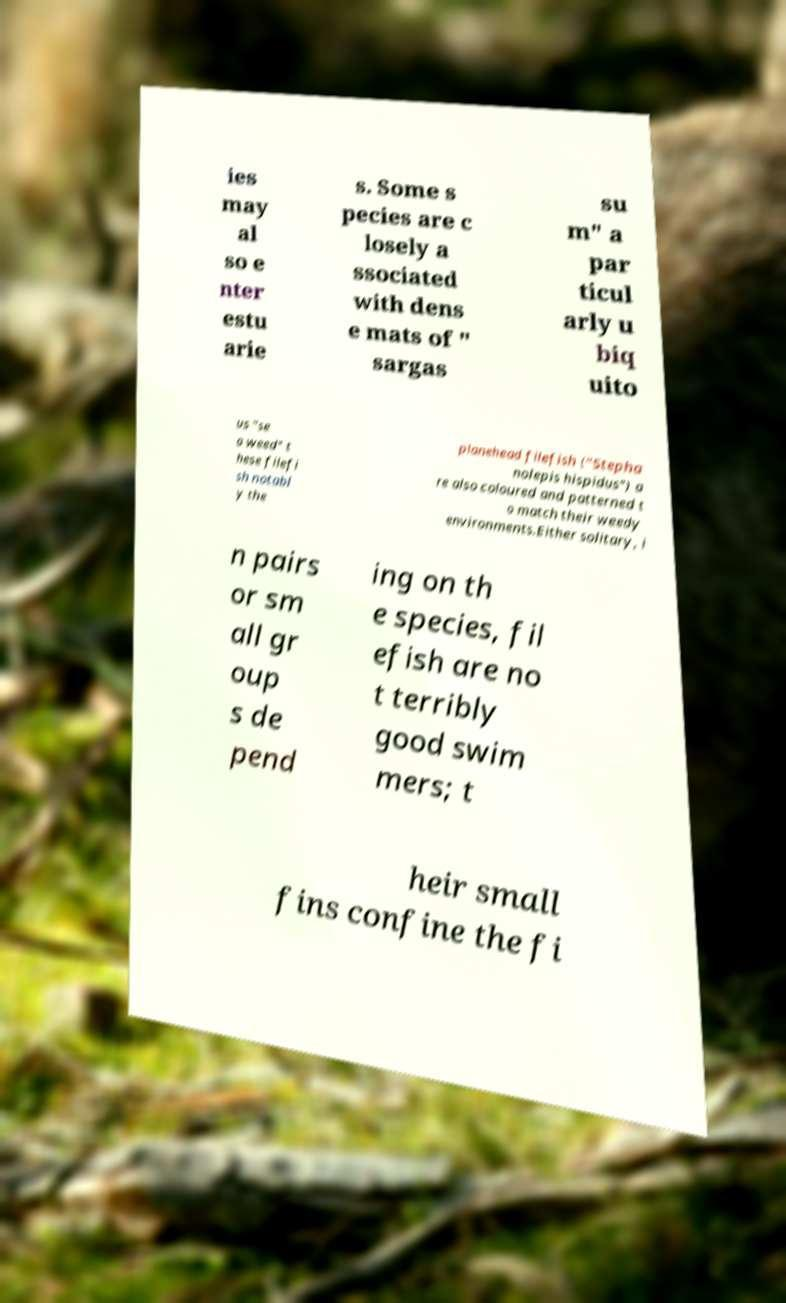Please read and relay the text visible in this image. What does it say? ies may al so e nter estu arie s. Some s pecies are c losely a ssociated with dens e mats of " sargas su m" a par ticul arly u biq uito us "se a weed" t hese filefi sh notabl y the planehead filefish ("Stepha nolepis hispidus") a re also coloured and patterned t o match their weedy environments.Either solitary, i n pairs or sm all gr oup s de pend ing on th e species, fil efish are no t terribly good swim mers; t heir small fins confine the fi 